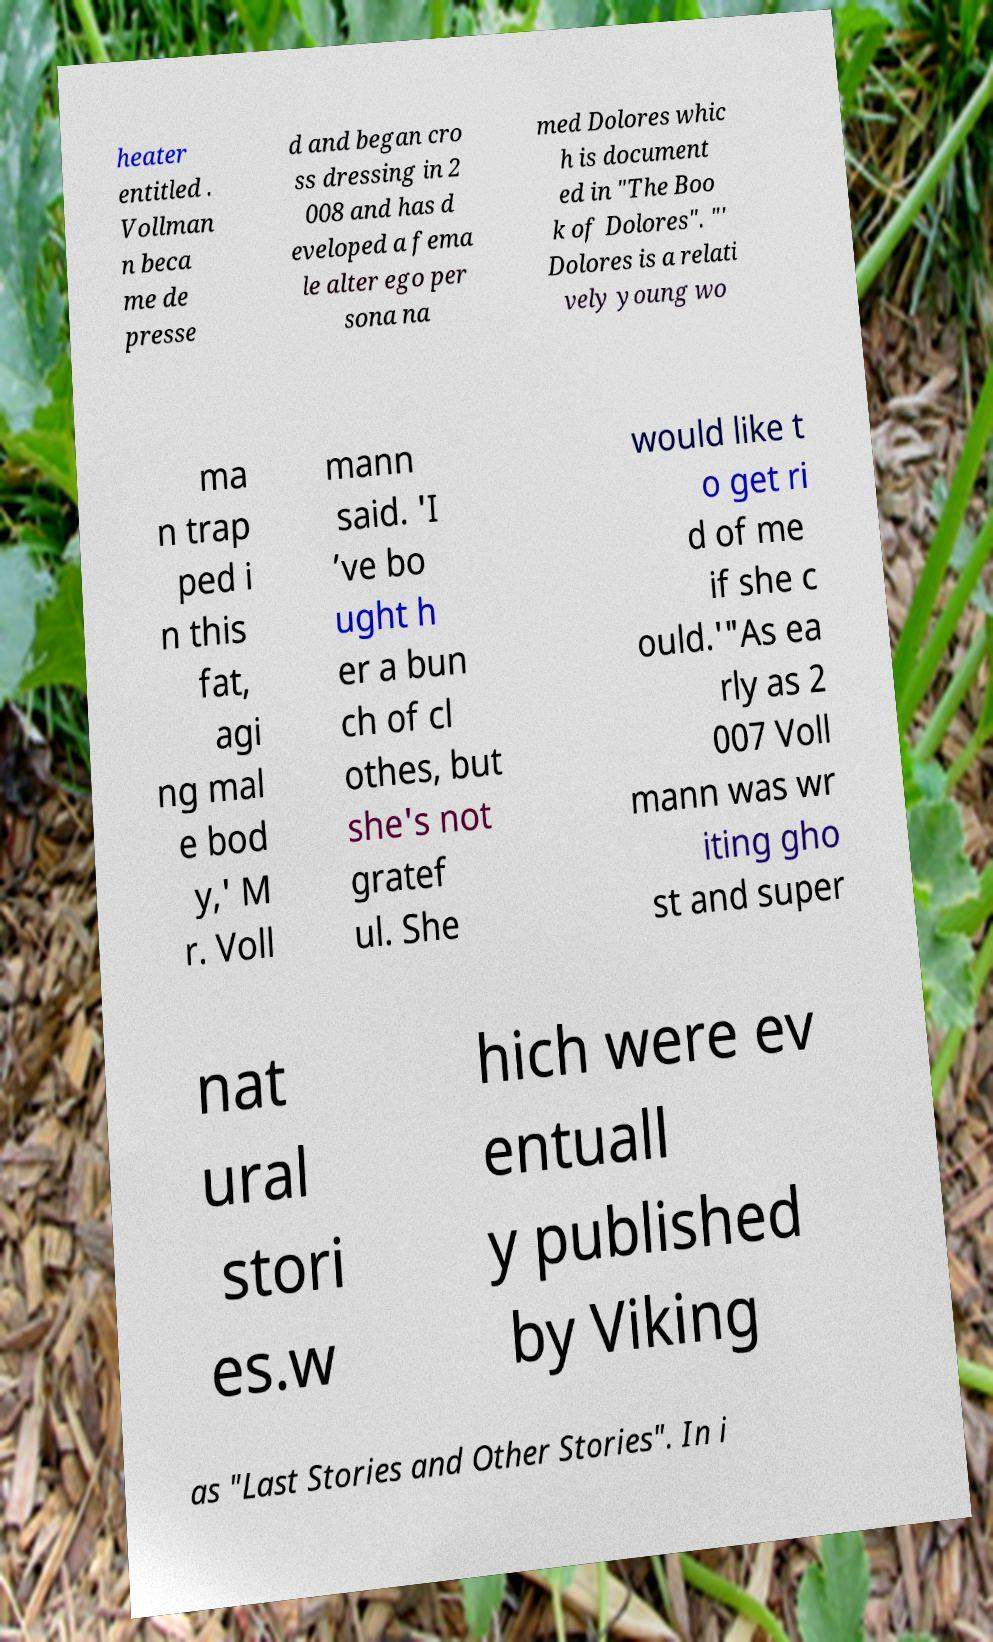Can you accurately transcribe the text from the provided image for me? heater entitled . Vollman n beca me de presse d and began cro ss dressing in 2 008 and has d eveloped a fema le alter ego per sona na med Dolores whic h is document ed in "The Boo k of Dolores". "' Dolores is a relati vely young wo ma n trap ped i n this fat, agi ng mal e bod y,' M r. Voll mann said. 'I ’ve bo ught h er a bun ch of cl othes, but she's not gratef ul. She would like t o get ri d of me if she c ould.'"As ea rly as 2 007 Voll mann was wr iting gho st and super nat ural stori es.w hich were ev entuall y published by Viking as "Last Stories and Other Stories". In i 